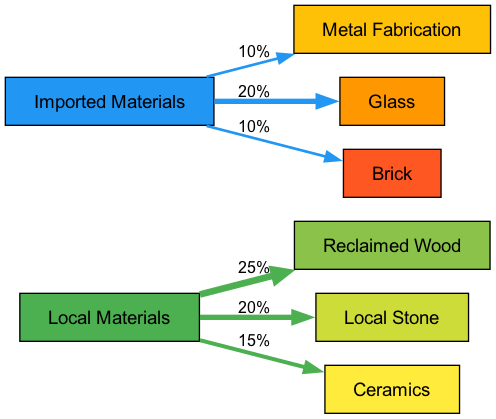What percentage of local materials is represented by reclaimed wood? The connection from "Local Materials" to "Reclaimed Wood" shows a value of 25%. This indicates that reclaimed wood constitutes 25% of the total local materials used.
Answer: 25% What are the two types of imported materials shown in the diagram? The diagram lists three targets under "Imported Materials": "Metal Fabrication," "Glass," and "Brick." The question asks for two, and any two can be selected based on appearance.
Answer: Metal Fabrication and Glass Which local material accounts for the smallest percentage? Examining the connections from "Local Materials," "Ceramics" has a value of 15%, which is less than both "Reclaimed Wood" (25%) and "Local Stone" (20%). Thus, it accounts for the smallest percentage among local materials.
Answer: Ceramics What is the total percentage of local materials used in urban designs in this diagram? The diagram shows the percentages for local materials: 25% (Reclaimed Wood) + 20% (Local Stone) + 15% (Ceramics), summing these values gives a total of 60%.
Answer: 60% Which imported material has the highest representation in the diagram? The values for imported materials are: "Metal Fabrication" (10%), "Glass" (20%), and "Brick" (10%). Clearly, "Glass" has the highest percentage at 20%.
Answer: Glass What is the relationship between local materials and ceramics? The diagram shows a direct connection from "Local Materials" to "Ceramics" with a flow of 15%. This indicates that ceramics is a subset of local materials, specifically accounting for 15% of the total.
Answer: 15% How many nodes are categorized as local materials? The diagram lists three types of local materials: "Reclaimed Wood," "Local Stone," and "Ceramics." Counting these gives a total of three local material nodes.
Answer: 3 What is the ratio of imported to local materials based on their total representations? The total of local materials is 60% and the sum of imported materials is 10% (Metal Fabrication) + 20% (Glass) + 10% (Brick) = 40%. Therefore, the ratio of imported to local materials is 40:60, which simplifies to 2:3.
Answer: 2:3 Why is the representation of imported materials lower than local materials in urban design? Analyzing the node values shows that local materials total 60%, while imported materials total only 40%. This imbalance suggests a preference or requirement for using local materials over imported ones, possibly due to sustainability or cultural significance in contemporary designs.
Answer: Preference for local materials 